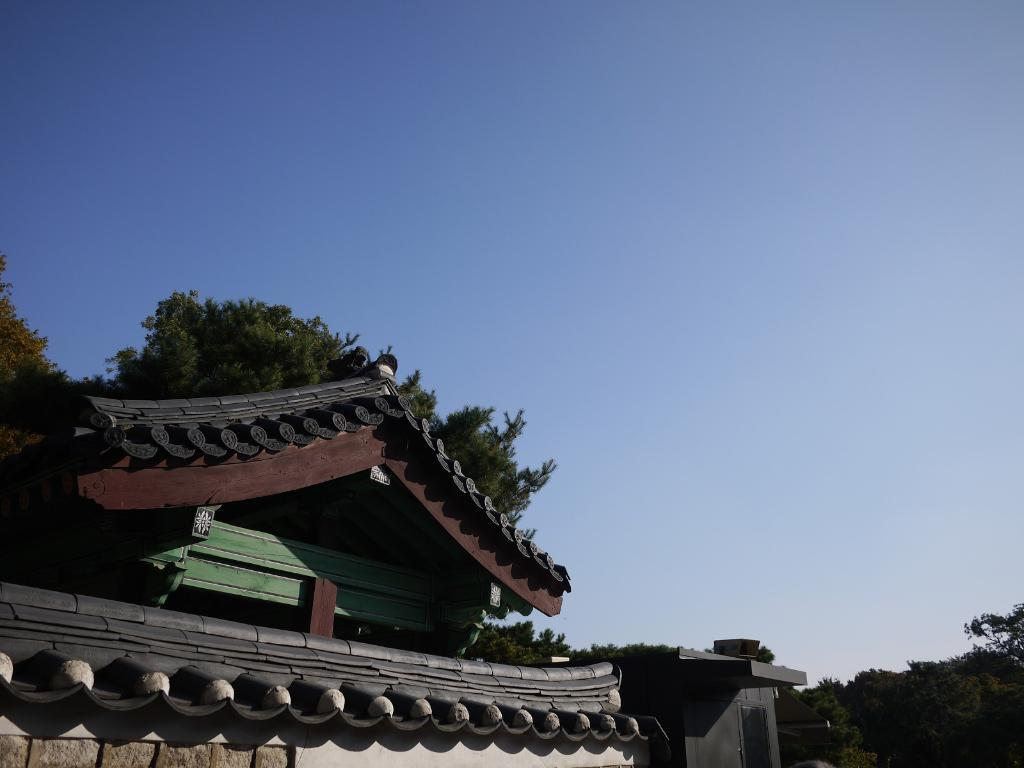What color is the sky in the image? The sky is blue in the image. What structures can be seen in the image? There are buildings in the image. What type of vegetation is present in the image? There are trees in the image. How many apples are hanging from the trees in the image? There are no apples present in the image; it only features trees and buildings. 